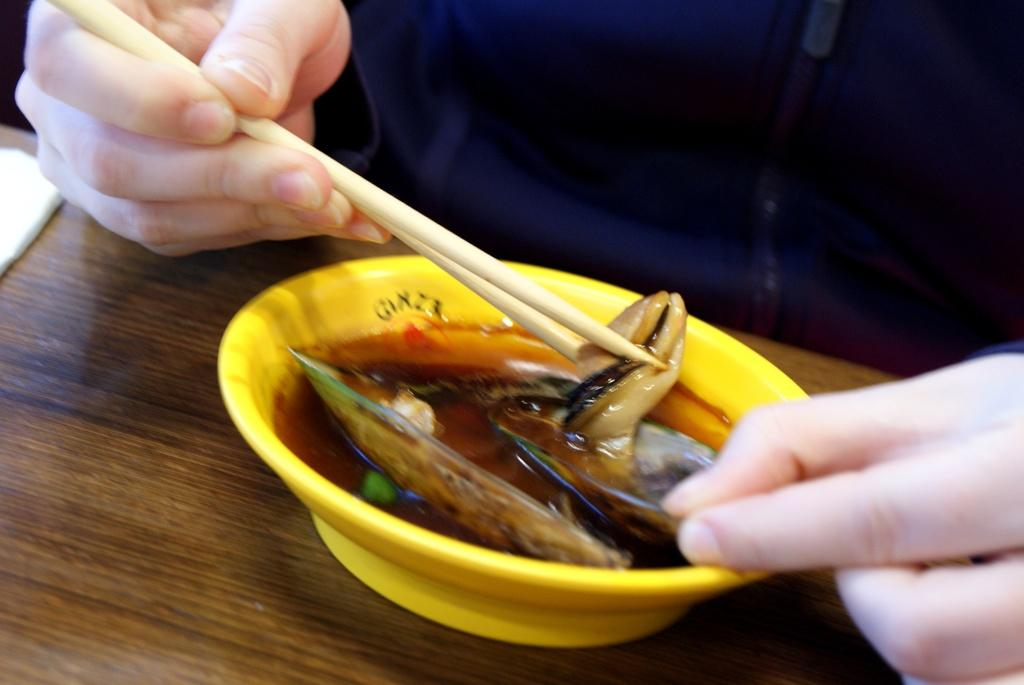What is the person in the image doing? The person is holding a chopstick. What object is present on the table in the image? There is a bowl with food on the table. Can you describe the table in the image? There is a table in the image. What type of stocking is the maid wearing on her leg in the image? There is no maid or stocking present in the image. Is the person in the image wearing a cast on their arm? There is no cast visible on the person in the image. 